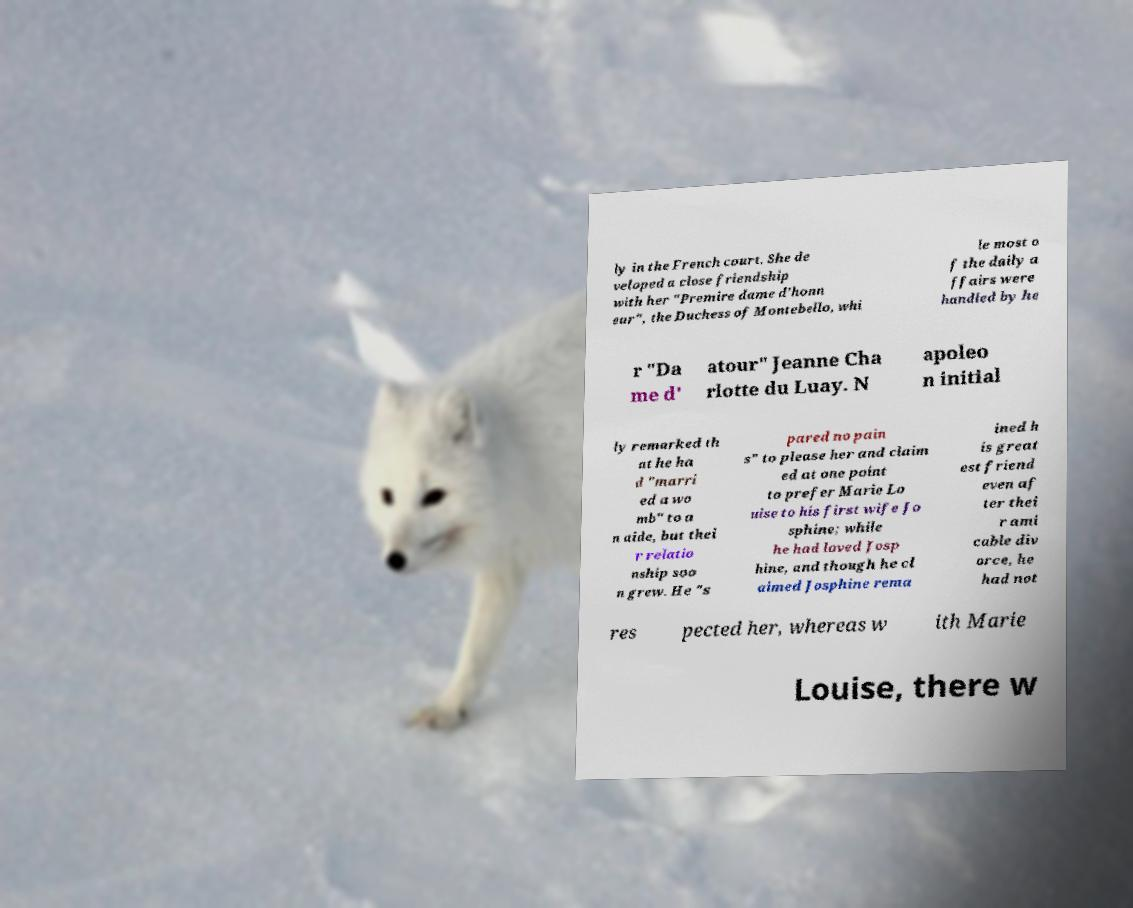I need the written content from this picture converted into text. Can you do that? ly in the French court. She de veloped a close friendship with her "Premire dame d'honn eur", the Duchess of Montebello, whi le most o f the daily a ffairs were handled by he r "Da me d' atour" Jeanne Cha rlotte du Luay. N apoleo n initial ly remarked th at he ha d "marri ed a wo mb" to a n aide, but thei r relatio nship soo n grew. He "s pared no pain s" to please her and claim ed at one point to prefer Marie Lo uise to his first wife Jo sphine; while he had loved Josp hine, and though he cl aimed Josphine rema ined h is great est friend even af ter thei r ami cable div orce, he had not res pected her, whereas w ith Marie Louise, there w 